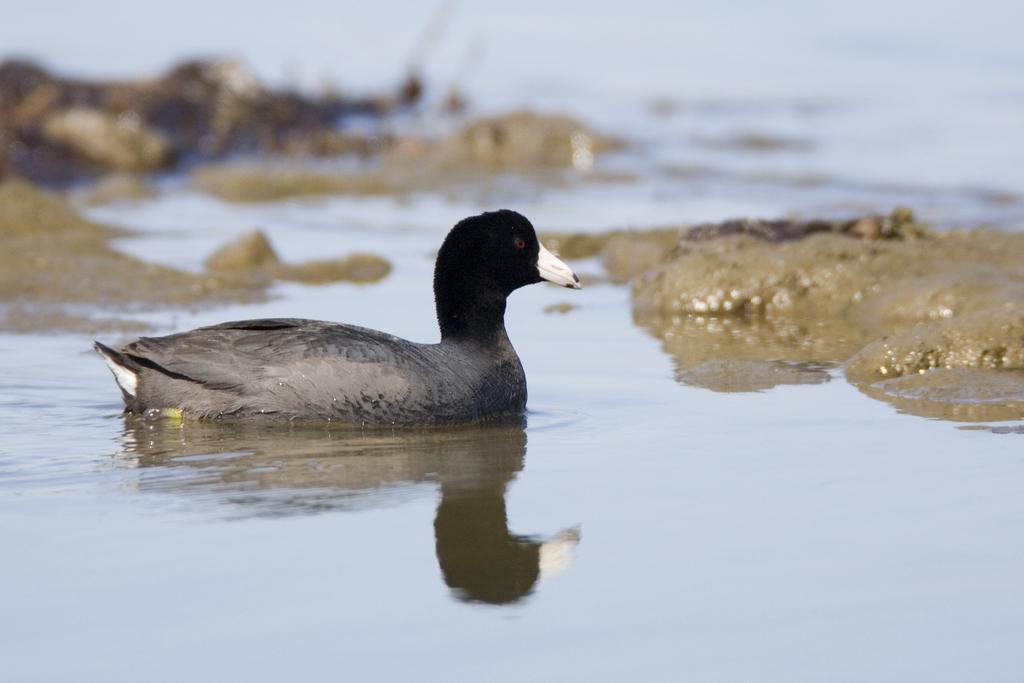Could you give a brief overview of what you see in this image? In the picture we can see a duck in the water and the duck is some part black in color and some part is gray in color and behind the dock we can see some rocks in the water and in the background also we can see some rocks which are not clearly visible. 